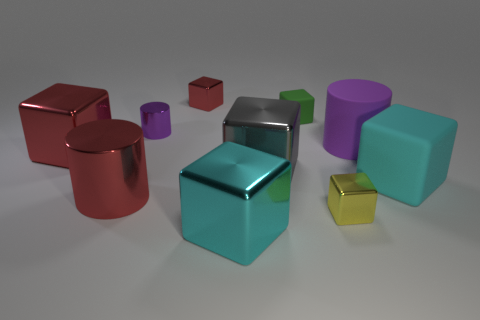What number of tiny metal objects are there?
Keep it short and to the point. 3. What color is the small metal object in front of the purple cylinder on the right side of the tiny metal block that is behind the large red block?
Make the answer very short. Yellow. Is the number of tiny yellow metal blocks less than the number of yellow matte things?
Your answer should be compact. No. What color is the other matte object that is the same shape as the tiny green object?
Keep it short and to the point. Cyan. What is the color of the tiny cylinder that is made of the same material as the large gray thing?
Keep it short and to the point. Purple. What number of yellow things have the same size as the green matte thing?
Give a very brief answer. 1. What is the big purple object made of?
Ensure brevity in your answer.  Rubber. Are there more small yellow metal things than cyan objects?
Your response must be concise. No. Does the tiny green matte object have the same shape as the purple metallic object?
Give a very brief answer. No. Is there anything else that has the same shape as the big gray shiny thing?
Make the answer very short. Yes. 